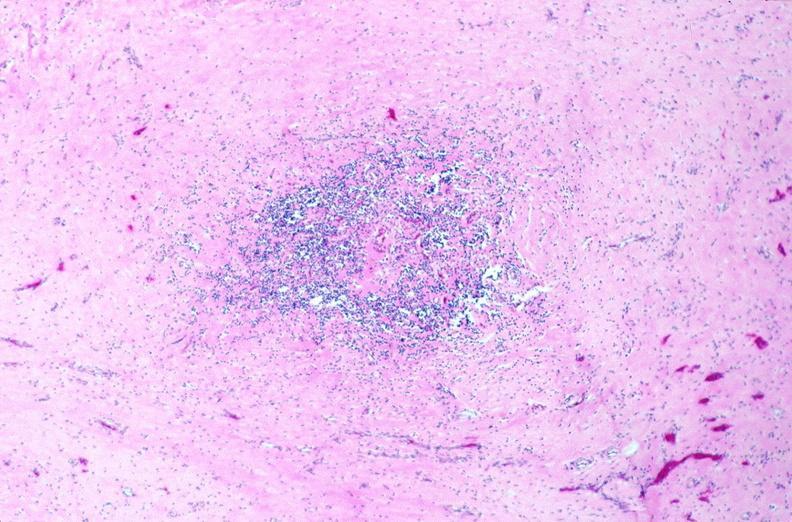does this image show lymph nodes, nodular sclerosing hodgkins disease?
Answer the question using a single word or phrase. Yes 